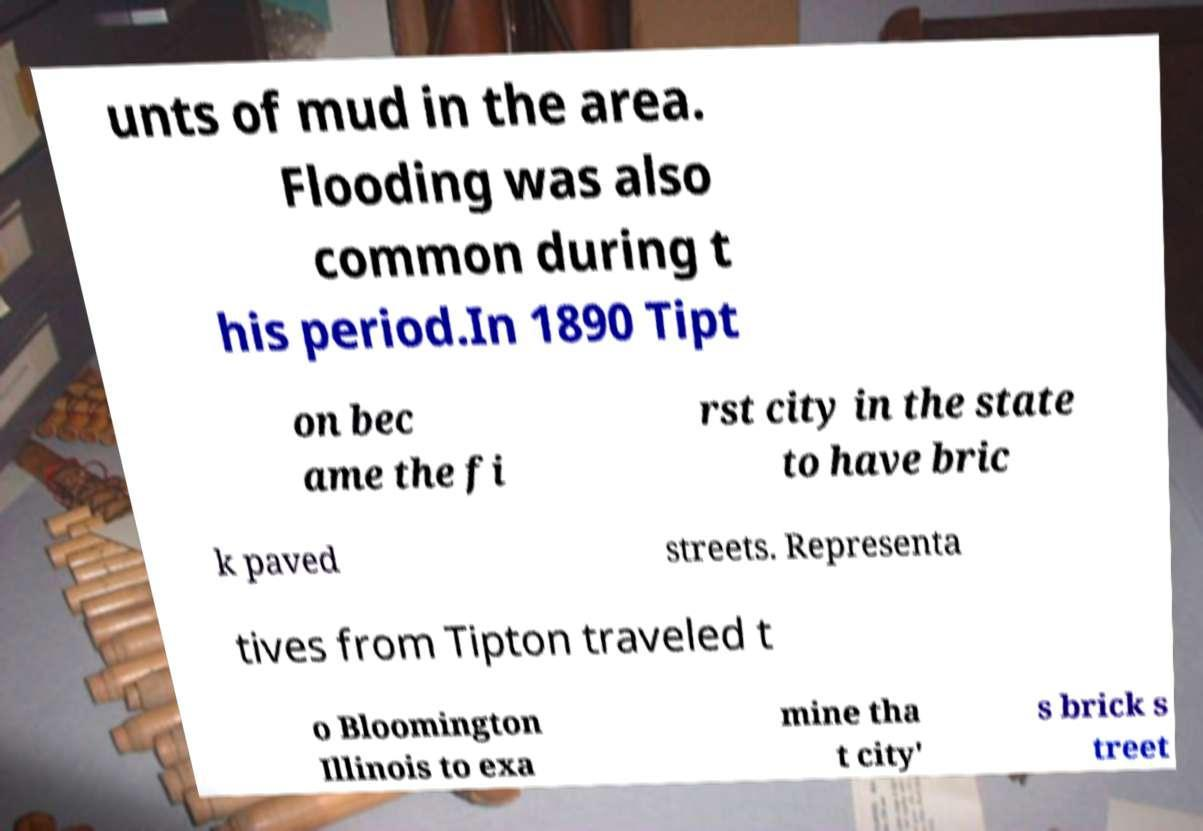There's text embedded in this image that I need extracted. Can you transcribe it verbatim? unts of mud in the area. Flooding was also common during t his period.In 1890 Tipt on bec ame the fi rst city in the state to have bric k paved streets. Representa tives from Tipton traveled t o Bloomington Illinois to exa mine tha t city' s brick s treet 